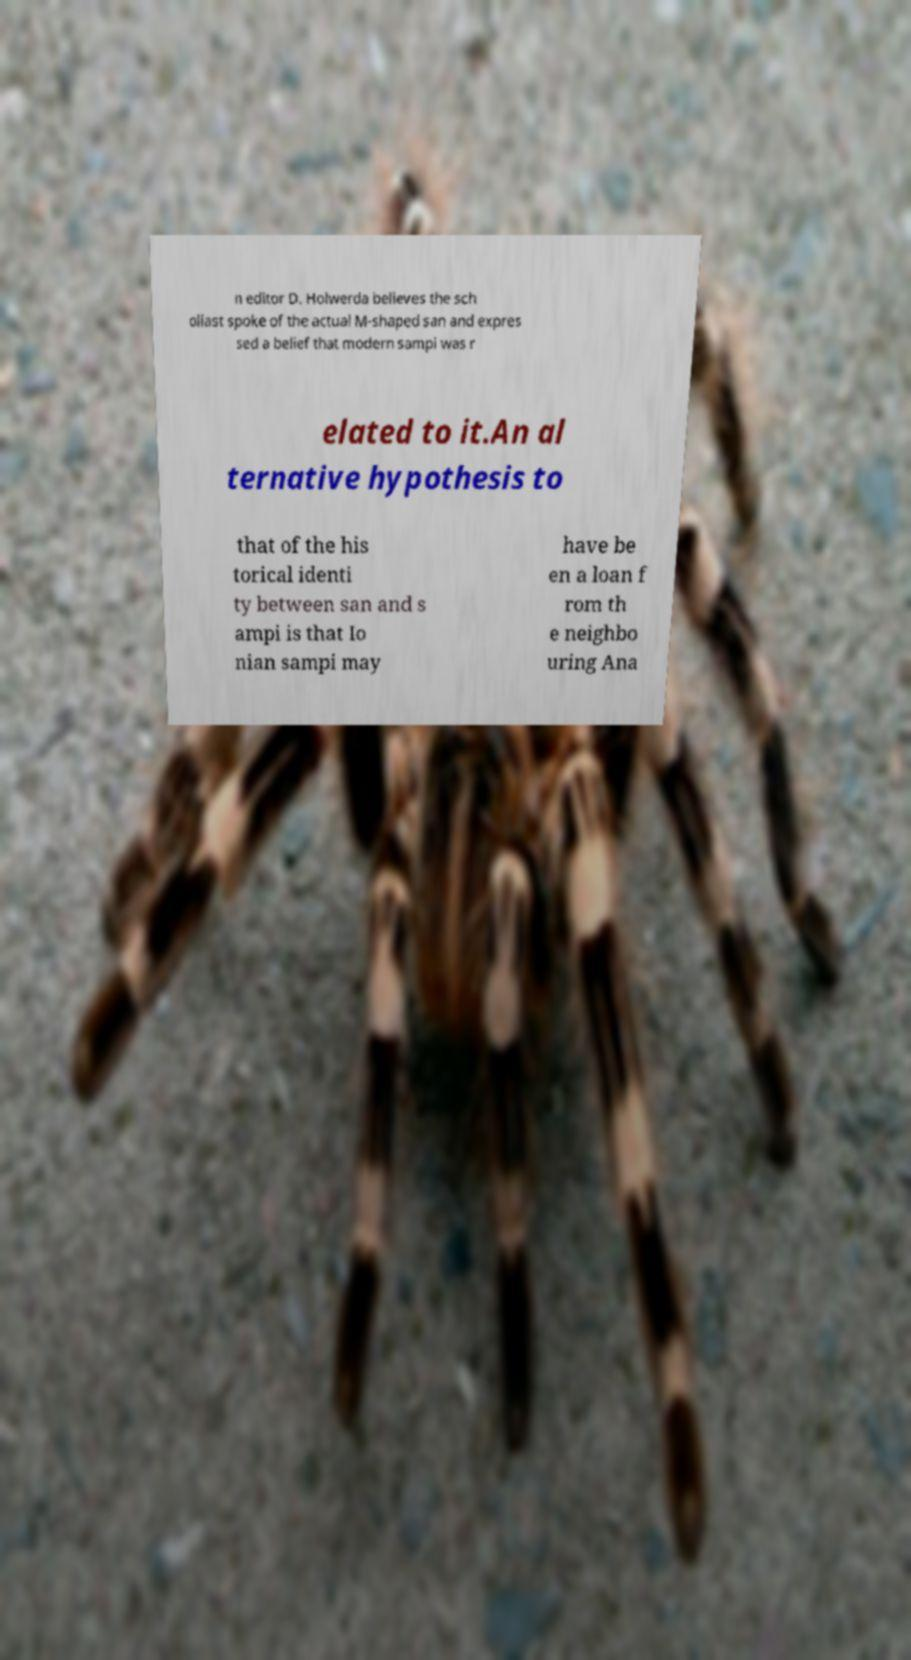What messages or text are displayed in this image? I need them in a readable, typed format. n editor D. Holwerda believes the sch oliast spoke of the actual M-shaped san and expres sed a belief that modern sampi was r elated to it.An al ternative hypothesis to that of the his torical identi ty between san and s ampi is that Io nian sampi may have be en a loan f rom th e neighbo uring Ana 